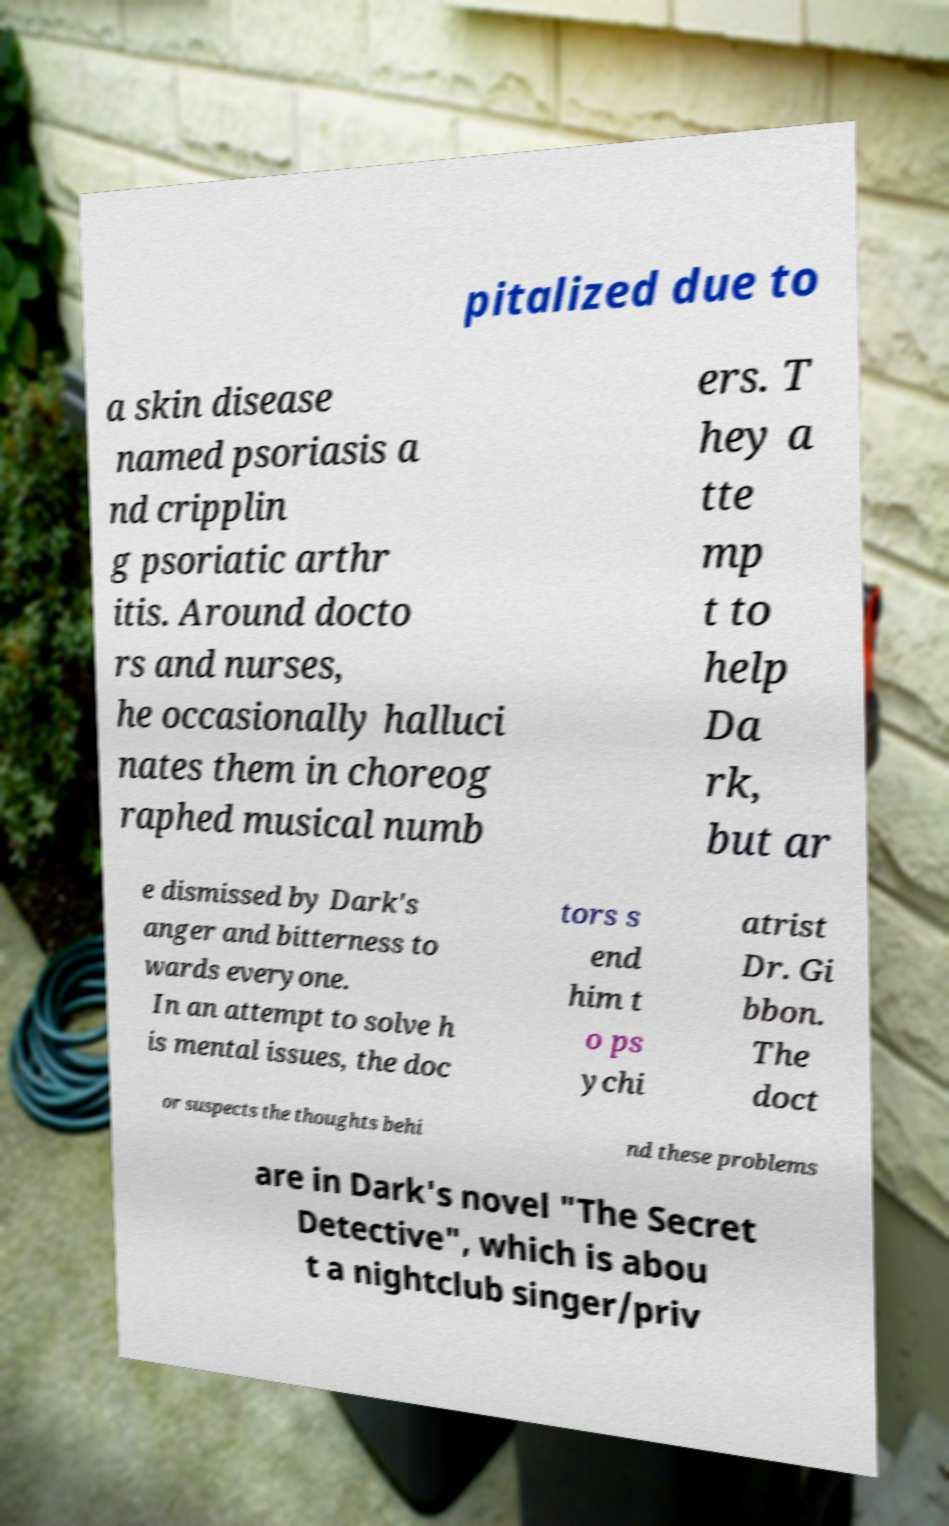I need the written content from this picture converted into text. Can you do that? pitalized due to a skin disease named psoriasis a nd cripplin g psoriatic arthr itis. Around docto rs and nurses, he occasionally halluci nates them in choreog raphed musical numb ers. T hey a tte mp t to help Da rk, but ar e dismissed by Dark's anger and bitterness to wards everyone. In an attempt to solve h is mental issues, the doc tors s end him t o ps ychi atrist Dr. Gi bbon. The doct or suspects the thoughts behi nd these problems are in Dark's novel "The Secret Detective", which is abou t a nightclub singer/priv 